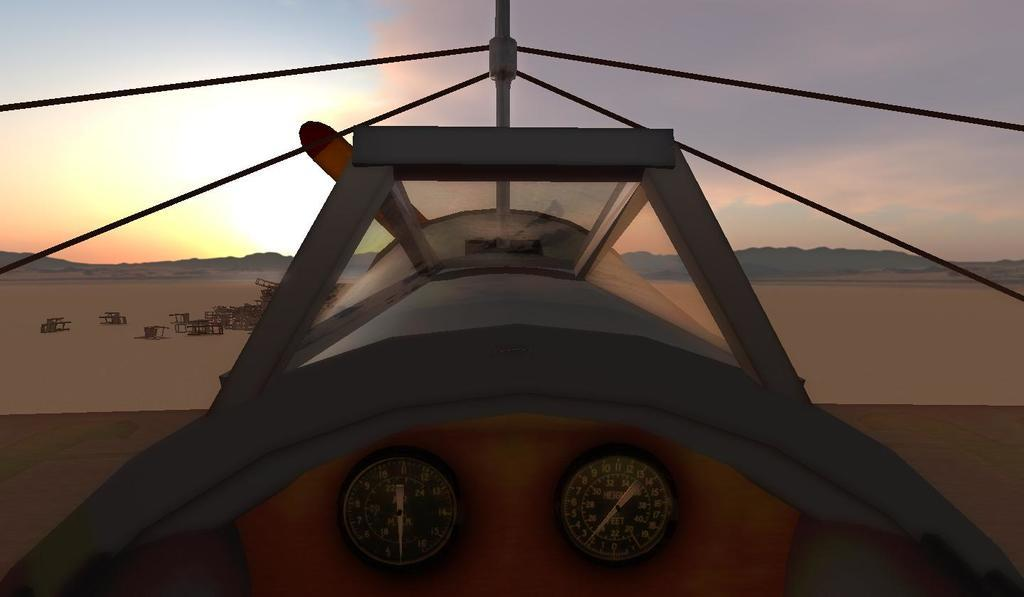Provide a one-sentence caption for the provided image. inside of small plane that has 2 gauges, one has words height feet and dial a little past 2. 